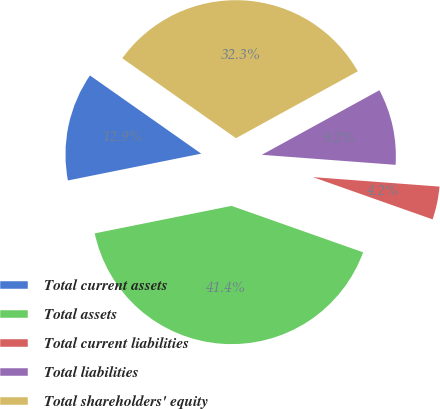Convert chart to OTSL. <chart><loc_0><loc_0><loc_500><loc_500><pie_chart><fcel>Total current assets<fcel>Total assets<fcel>Total current liabilities<fcel>Total liabilities<fcel>Total shareholders' equity<nl><fcel>12.91%<fcel>41.44%<fcel>4.21%<fcel>9.18%<fcel>32.26%<nl></chart> 